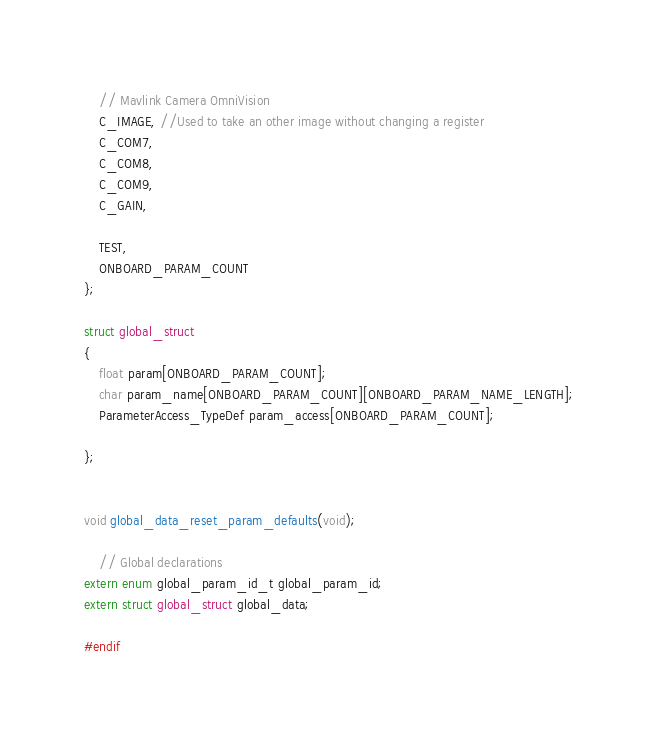Convert code to text. <code><loc_0><loc_0><loc_500><loc_500><_C_>	// Mavlink Camera OmniVision
	C_IMAGE, //Used to take an other image without changing a register
	C_COM7, 
	C_COM8,
	C_COM9,
	C_GAIN,
	
	TEST,
	ONBOARD_PARAM_COUNT
};

struct global_struct
{
	float param[ONBOARD_PARAM_COUNT];
	char param_name[ONBOARD_PARAM_COUNT][ONBOARD_PARAM_NAME_LENGTH];
	ParameterAccess_TypeDef param_access[ONBOARD_PARAM_COUNT];
	
};


void global_data_reset_param_defaults(void);

	// Global declarations
extern enum global_param_id_t global_param_id;
extern struct global_struct global_data;

#endif</code> 